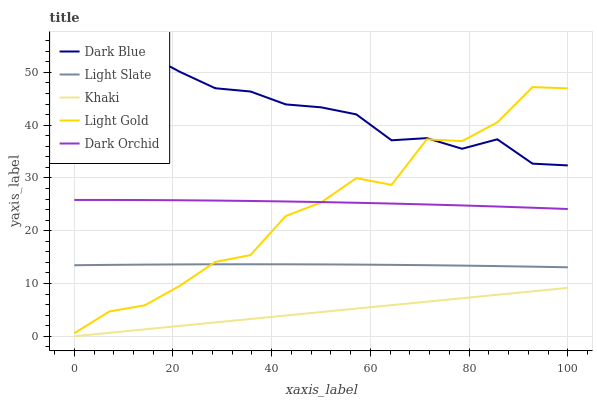Does Khaki have the minimum area under the curve?
Answer yes or no. Yes. Does Dark Blue have the maximum area under the curve?
Answer yes or no. Yes. Does Dark Blue have the minimum area under the curve?
Answer yes or no. No. Does Khaki have the maximum area under the curve?
Answer yes or no. No. Is Khaki the smoothest?
Answer yes or no. Yes. Is Light Gold the roughest?
Answer yes or no. Yes. Is Dark Blue the smoothest?
Answer yes or no. No. Is Dark Blue the roughest?
Answer yes or no. No. Does Khaki have the lowest value?
Answer yes or no. Yes. Does Dark Blue have the lowest value?
Answer yes or no. No. Does Dark Blue have the highest value?
Answer yes or no. Yes. Does Khaki have the highest value?
Answer yes or no. No. Is Khaki less than Light Slate?
Answer yes or no. Yes. Is Dark Blue greater than Light Slate?
Answer yes or no. Yes. Does Dark Orchid intersect Light Gold?
Answer yes or no. Yes. Is Dark Orchid less than Light Gold?
Answer yes or no. No. Is Dark Orchid greater than Light Gold?
Answer yes or no. No. Does Khaki intersect Light Slate?
Answer yes or no. No. 